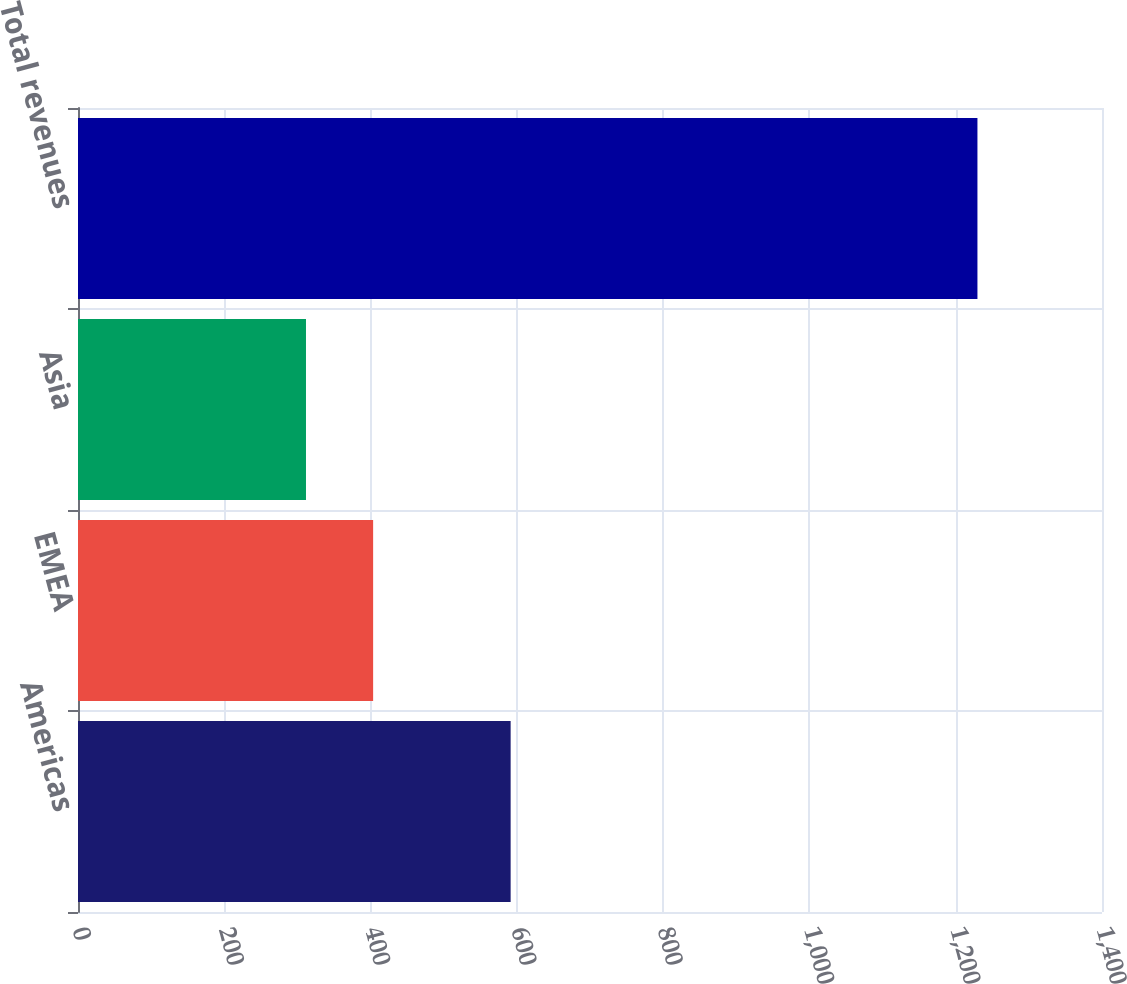<chart> <loc_0><loc_0><loc_500><loc_500><bar_chart><fcel>Americas<fcel>EMEA<fcel>Asia<fcel>Total revenues<nl><fcel>591.5<fcel>403.5<fcel>311.7<fcel>1229.7<nl></chart> 